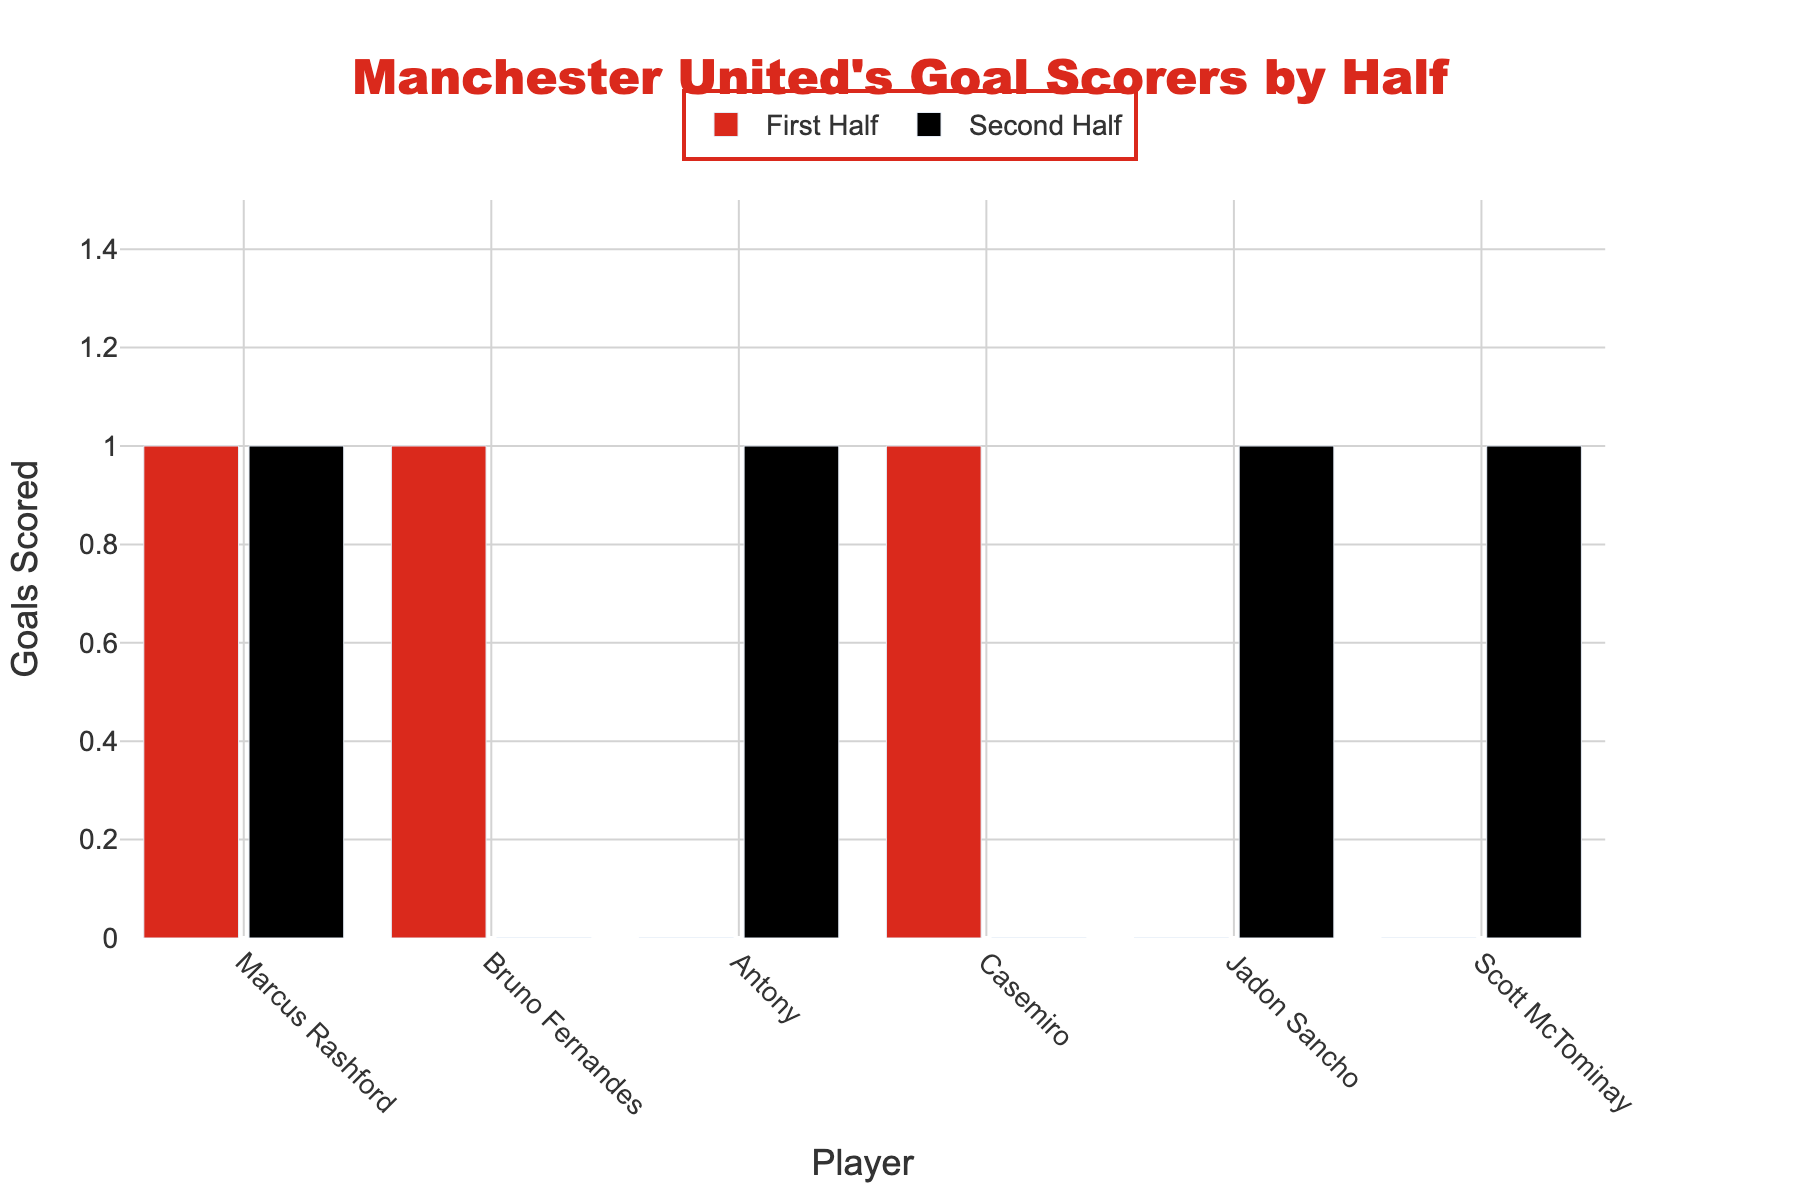Which player scored the most goals in the first half? Check the heights of the red bars for each player. Marcus Rashford, Bruno Fernandes, and Casemiro each have a single red bar at the maximum height of 1.
Answer: Marcus Rashford, Bruno Fernandes, and Casemiro Which player did not score any goals in the first half but scored in the second half? Look for a player with no red bar but a noticeable black bar. Jadon Sancho, Antony, and Scott McTominay fit this description.
Answer: Jadon Sancho, Antony, Scott McTominay How many total goals did Marcus Rashford score? Add the heights of Marcus Rashford’s red and black bars: 1 (first half) + 1 (second half) = 2 goals.
Answer: 2 Who scored more goals in the second half, Jadon Sancho or Scott McTominay? Compare the heights of the black bars for Jadon Sancho and Scott McTominay. Both have a black bar height of 1.
Answer: Equal What's the total number of goals scored in the second half by all players? Sum the heights of all black bars: 1 (Rashford) + 1 (Antony) + 1 (Sancho) + 1 (McTominay) = 4.
Answer: 4 Calculate the difference in total goals scored between the first half and second half. Sum the heights of all red bars and compare with the sum of all black bars: 3 (first half) - 4 (second half) = -1.
Answer: -1 Which player scored an equal number of goals in both halves? Compare the red and black bars for each player. Only Marcus Rashford has equal heights: 1 red and 1 black.
Answer: Marcus Rashford How many players scored exactly one goal in the match? Identify players with combined red and black bar heights of 1: Fernandes, Casemiro, Antony, Sancho, McTominay = 5 players.
Answer: 5 